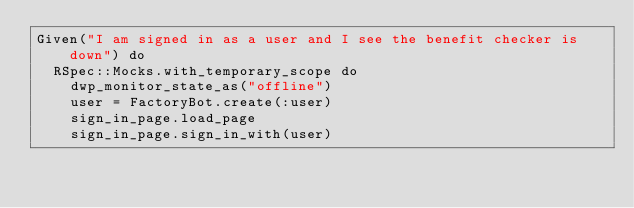<code> <loc_0><loc_0><loc_500><loc_500><_Ruby_>Given("I am signed in as a user and I see the benefit checker is down") do
  RSpec::Mocks.with_temporary_scope do
    dwp_monitor_state_as("offline")
    user = FactoryBot.create(:user)
    sign_in_page.load_page
    sign_in_page.sign_in_with(user)</code> 